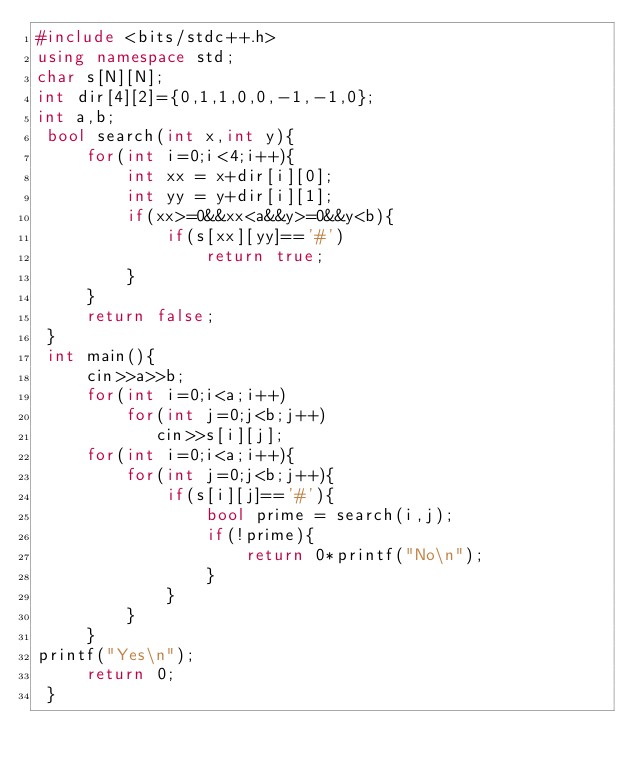Convert code to text. <code><loc_0><loc_0><loc_500><loc_500><_C++_>#include <bits/stdc++.h>
using namespace std;
char s[N][N];
int dir[4][2]={0,1,1,0,0,-1,-1,0};
int a,b; 
 bool search(int x,int y){
     for(int i=0;i<4;i++){
         int xx = x+dir[i][0];
         int yy = y+dir[i][1];
         if(xx>=0&&xx<a&&y>=0&&y<b){
             if(s[xx][yy]=='#')
                 return true;
         }
     }
     return false;
 }
 int main(){
     cin>>a>>b;
     for(int i=0;i<a;i++)
         for(int j=0;j<b;j++)
            cin>>s[i][j];
     for(int i=0;i<a;i++){
         for(int j=0;j<b;j++){
             if(s[i][j]=='#'){
                 bool prime = search(i,j);
                 if(!prime){
                     return 0*printf("No\n");
                 }
             }
         }
     }
printf("Yes\n");
     return 0;
 }</code> 